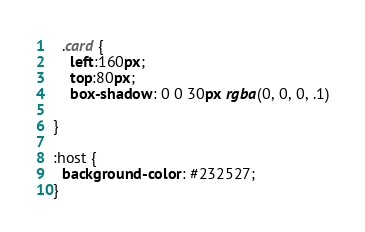<code> <loc_0><loc_0><loc_500><loc_500><_CSS_>

  .card {
    left:160px;
    top:80px;
    box-shadow: 0 0 30px rgba(0, 0, 0, .1)
    
}

:host {
  background-color: #232527;
}</code> 